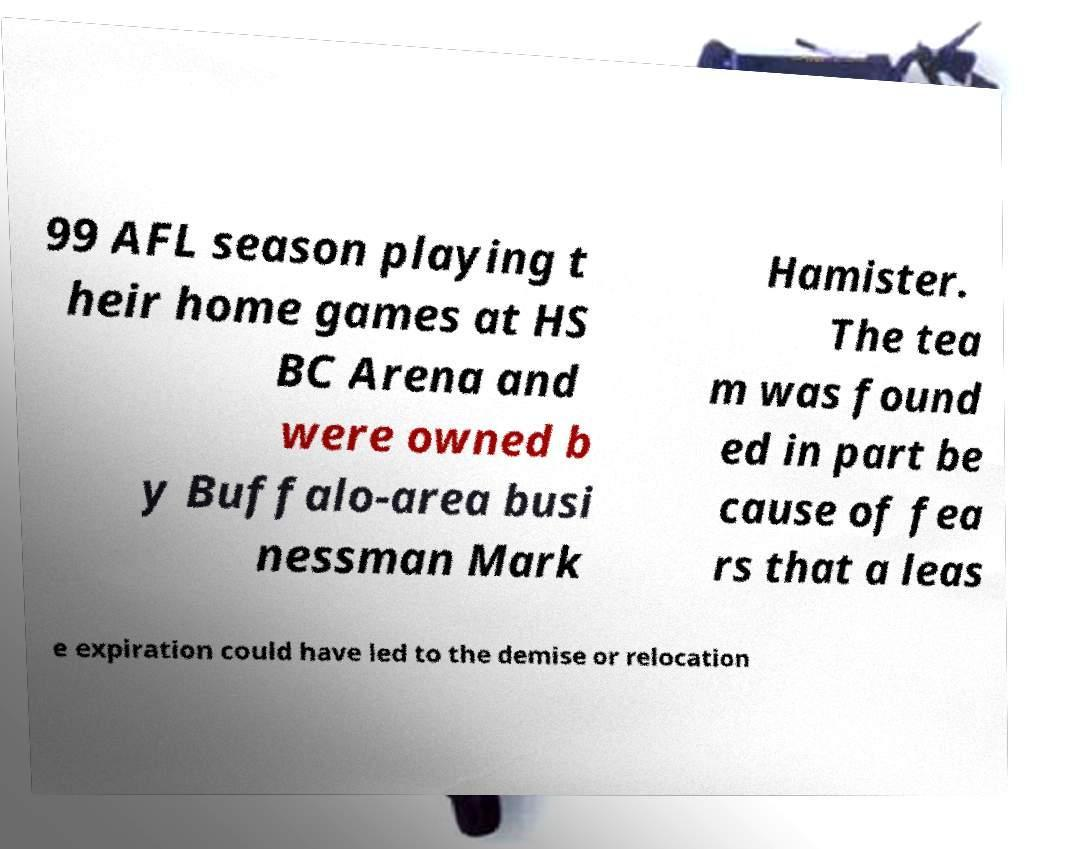Please identify and transcribe the text found in this image. 99 AFL season playing t heir home games at HS BC Arena and were owned b y Buffalo-area busi nessman Mark Hamister. The tea m was found ed in part be cause of fea rs that a leas e expiration could have led to the demise or relocation 